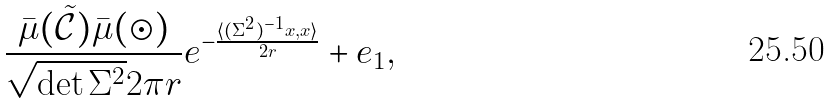Convert formula to latex. <formula><loc_0><loc_0><loc_500><loc_500>\frac { \bar { \mu } ( \tilde { \mathcal { C } } ) \bar { \mu } ( \odot ) } { \sqrt { \det \Sigma ^ { 2 } } 2 \pi r } e ^ { - \frac { \langle ( \Sigma ^ { 2 } ) ^ { - 1 } x , x \rangle } { 2 r } } + e _ { 1 } ,</formula> 